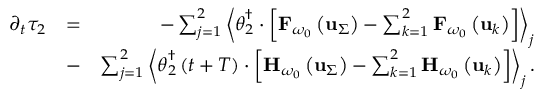<formula> <loc_0><loc_0><loc_500><loc_500>\begin{array} { r l r } { \partial _ { t } \tau _ { 2 } } & { = } & { - \sum _ { j = 1 } ^ { 2 } \left \langle \theta _ { 2 } ^ { \dagger } \cdot \left [ { F } _ { \omega _ { 0 } } \left ( { u } _ { \Sigma } \right ) - \sum _ { k = 1 } ^ { 2 } { F } _ { \omega _ { 0 } } \left ( { u } _ { k } \right ) \right ] \right \rangle _ { j } } \\ & { - } & { \sum _ { j = 1 } ^ { 2 } \left \langle \theta _ { 2 } ^ { \dagger } \left ( t + T \right ) \cdot \left [ { H } _ { \omega _ { 0 } } \left ( { u } _ { \Sigma } \right ) - \sum _ { k = 1 } ^ { 2 } { H } _ { \omega _ { 0 } } \left ( { u } _ { k } \right ) \right ] \right \rangle _ { j } . } \end{array}</formula> 